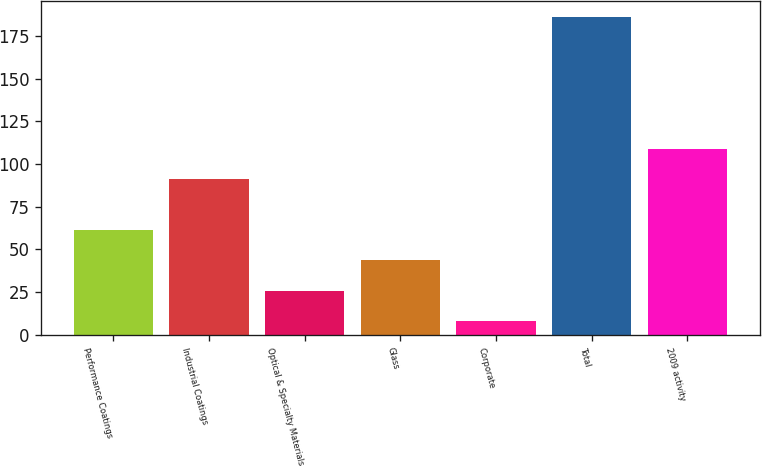Convert chart. <chart><loc_0><loc_0><loc_500><loc_500><bar_chart><fcel>Performance Coatings<fcel>Industrial Coatings<fcel>Optical & Specialty Materials<fcel>Glass<fcel>Corporate<fcel>Total<fcel>2009 activity<nl><fcel>61.4<fcel>91<fcel>25.8<fcel>43.6<fcel>8<fcel>186<fcel>109<nl></chart> 